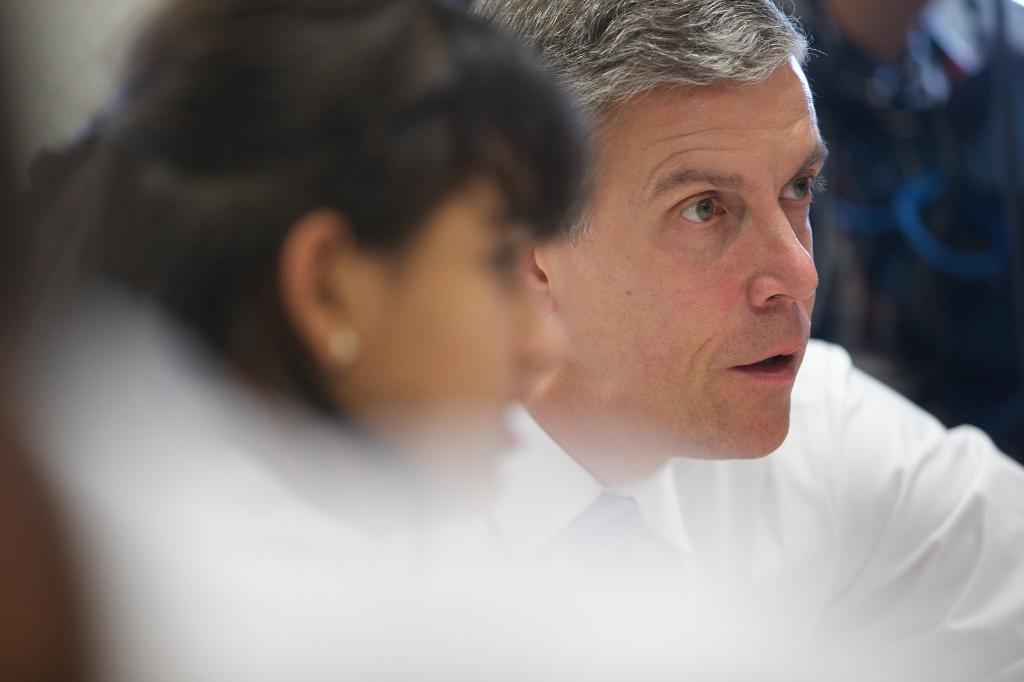How many people are in the image? There are two people in the image, a man and a woman. What are the man and woman doing in the image? The man and woman are looking at something. What is the man wearing in the image? The man is wearing a white shirt. What type of system is the tramp using to make adjustments in the image? There is no tramp or system present in the image. What type of adjustment is the man making to the woman's crib in the image? There is no crib or adjustment present in the image. 